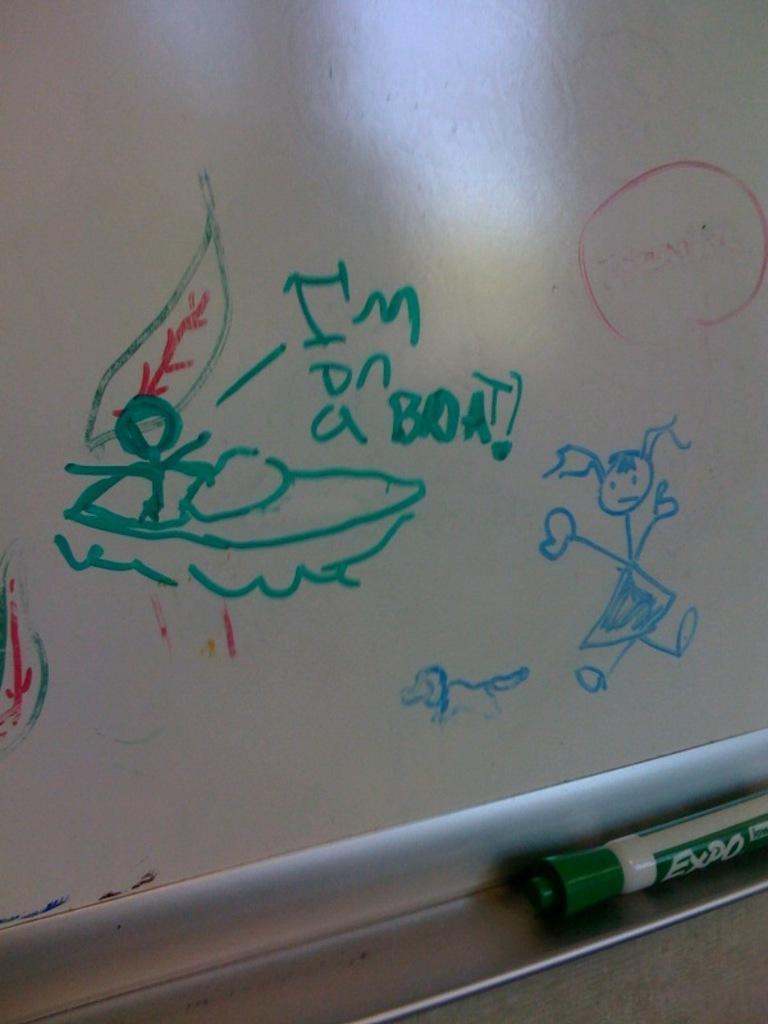Please provide a concise description of this image. This is the picture of a board. In this image there is a sketch of a person, dog and the boat and there is a sketch of leaves and there is a text on the board. At the bottom there is a marker. 